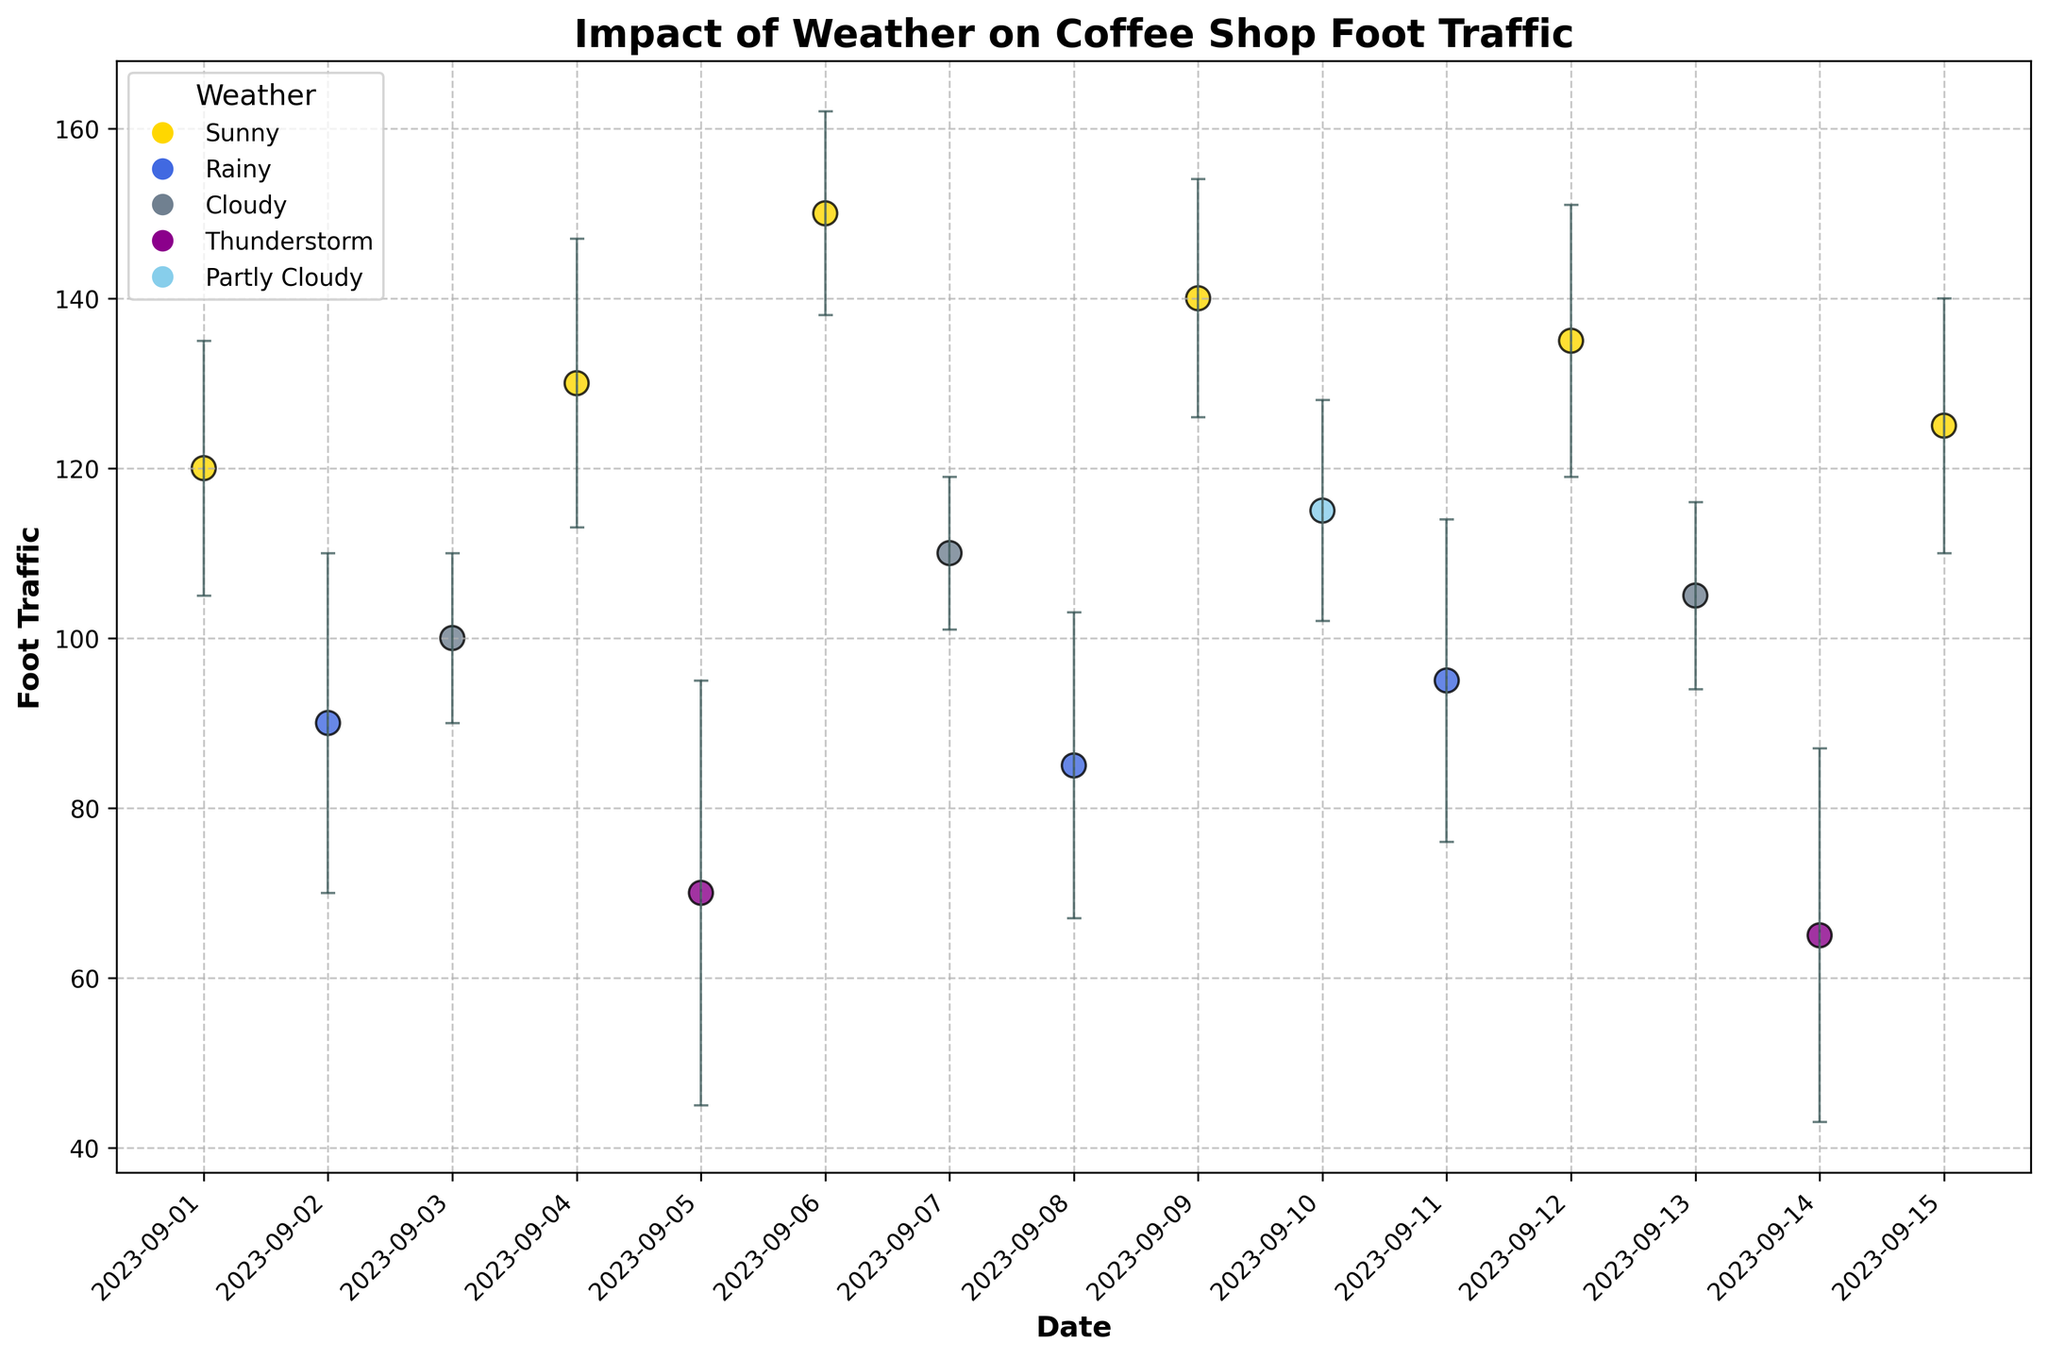What is the title of the plot? The title of the plot is displayed at the top of the figure in bold text.
Answer: Impact of Weather on Coffee Shop Foot Traffic What is the date with the highest foot traffic? To find the date with the highest foot traffic, look for the highest y-value on the scatter plot.
Answer: 2023-09-06 Which weather condition is associated with the lowest foot traffic? Examine the colors of the data points and find the one with the lowest y-value, then refer to the corresponding weather condition in the legend.
Answer: Thunderstorm How does the foot traffic on sunny days compare to rainy days? Compare the y-values of data points colored for sunny weather (yellow) to those for rainy weather (blue). Sunny data points generally have higher foot traffic.
Answer: Sunny days have higher foot traffic Which date has the highest variability in foot traffic? Look at the error bars of the points to find the one with the largest error margin in y-value.
Answer: 2023-09-05 What’s the range of foot traffic displayed in the chart? Find the minimum and maximum foot traffic values among all data points.
Answer: 65 to 150 Do sunny days consistently have high foot traffic? Evaluate the y-values of the data points for sunny weather to see if they are generally high. Sunny days have foot traffic values like 120, 130, 150, 140, 135, 125.
Answer: Yes Which date has the smallest error bar? Look at the error bars and find the date with the smallest error margin in y-value.
Answer: 2023-09-07 How does foot traffic variability on rainy days compare to cloudy days? Compare the length of the error bars of points for rainy weather (blue) to those for cloudy weather (grey). Rainy days have larger error bars.
Answer: Rainy days have higher variability 